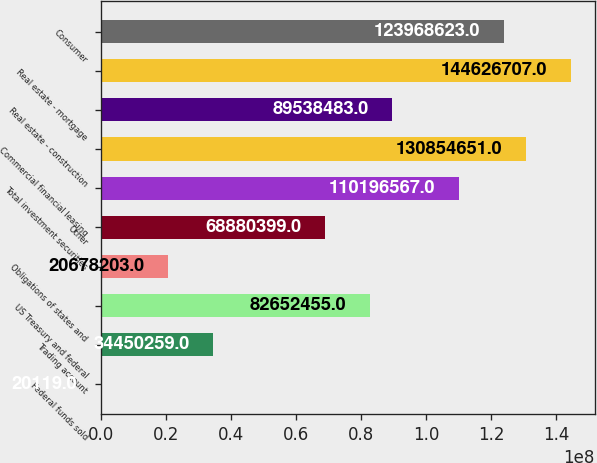Convert chart to OTSL. <chart><loc_0><loc_0><loc_500><loc_500><bar_chart><fcel>Federal funds sold<fcel>Trading account<fcel>US Treasury and federal<fcel>Obligations of states and<fcel>Other<fcel>Total investment securities<fcel>Commercial financial leasing<fcel>Real estate - construction<fcel>Real estate - mortgage<fcel>Consumer<nl><fcel>20119<fcel>3.44503e+07<fcel>8.26525e+07<fcel>2.06782e+07<fcel>6.88804e+07<fcel>1.10197e+08<fcel>1.30855e+08<fcel>8.95385e+07<fcel>1.44627e+08<fcel>1.23969e+08<nl></chart> 